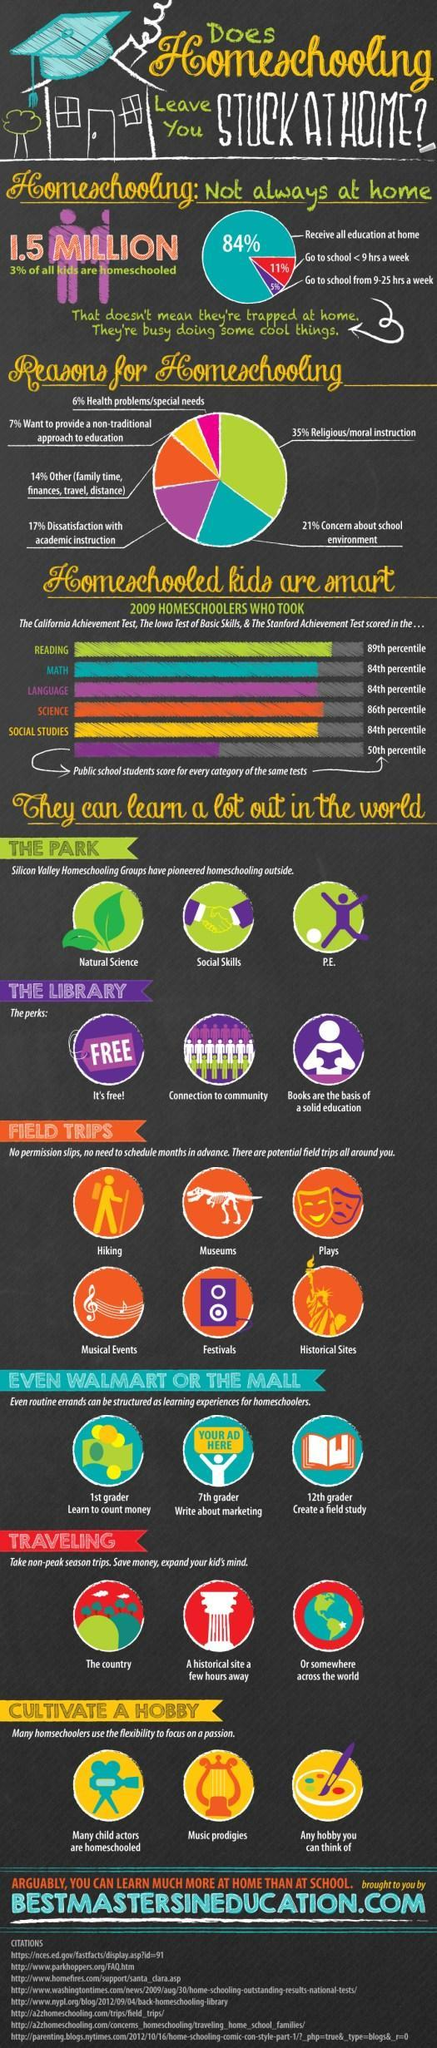Which has the highest share-go to school<9hrs a week, receive all education at home?
Answer the question with a short phrase. receive all education at home What percentage of religious and health problems together become the reasons for homeschooling? 41% How many reasons for homeschooling mentioned in this infographic? 6 What percentage of all kids are not homeschooled? 97% 